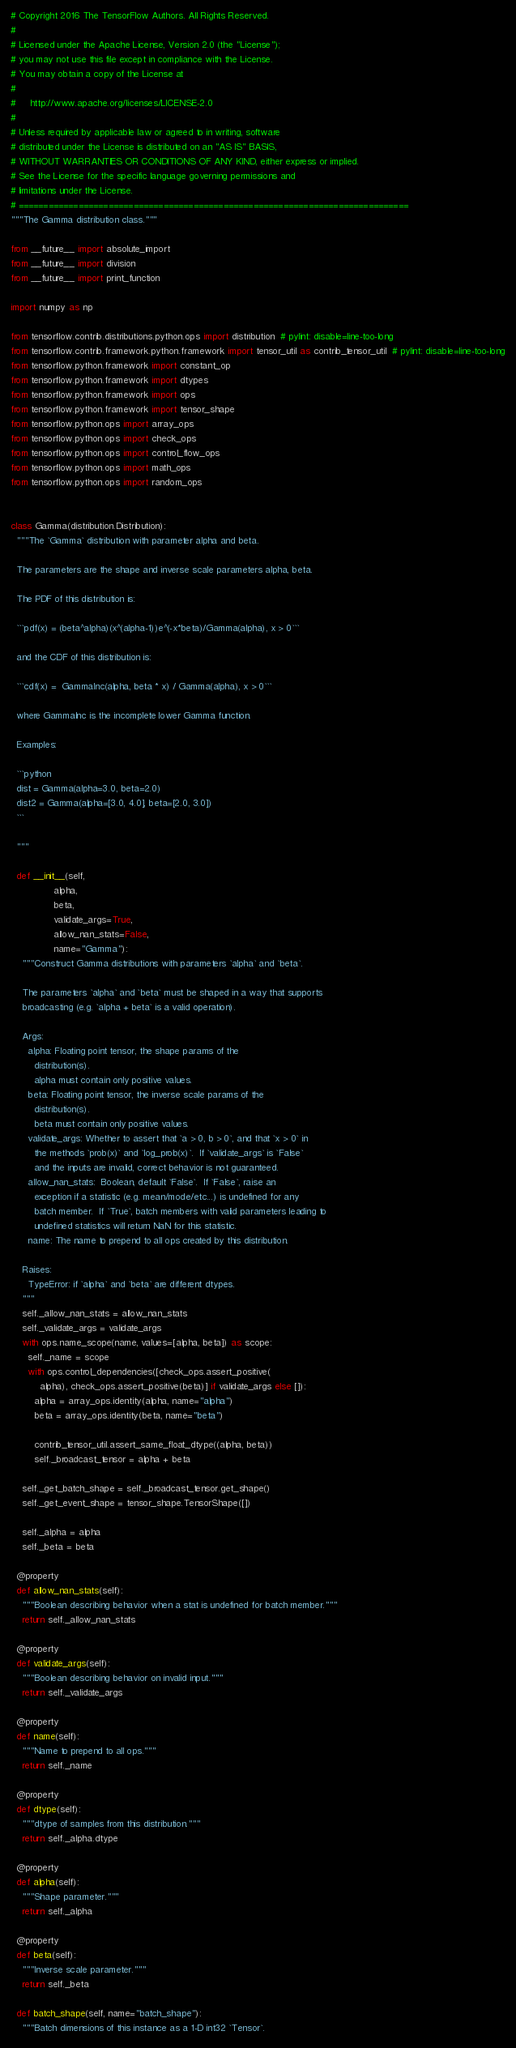Convert code to text. <code><loc_0><loc_0><loc_500><loc_500><_Python_># Copyright 2016 The TensorFlow Authors. All Rights Reserved.
#
# Licensed under the Apache License, Version 2.0 (the "License");
# you may not use this file except in compliance with the License.
# You may obtain a copy of the License at
#
#     http://www.apache.org/licenses/LICENSE-2.0
#
# Unless required by applicable law or agreed to in writing, software
# distributed under the License is distributed on an "AS IS" BASIS,
# WITHOUT WARRANTIES OR CONDITIONS OF ANY KIND, either express or implied.
# See the License for the specific language governing permissions and
# limitations under the License.
# ==============================================================================
"""The Gamma distribution class."""

from __future__ import absolute_import
from __future__ import division
from __future__ import print_function

import numpy as np

from tensorflow.contrib.distributions.python.ops import distribution  # pylint: disable=line-too-long
from tensorflow.contrib.framework.python.framework import tensor_util as contrib_tensor_util  # pylint: disable=line-too-long
from tensorflow.python.framework import constant_op
from tensorflow.python.framework import dtypes
from tensorflow.python.framework import ops
from tensorflow.python.framework import tensor_shape
from tensorflow.python.ops import array_ops
from tensorflow.python.ops import check_ops
from tensorflow.python.ops import control_flow_ops
from tensorflow.python.ops import math_ops
from tensorflow.python.ops import random_ops


class Gamma(distribution.Distribution):
  """The `Gamma` distribution with parameter alpha and beta.

  The parameters are the shape and inverse scale parameters alpha, beta.

  The PDF of this distribution is:

  ```pdf(x) = (beta^alpha)(x^(alpha-1))e^(-x*beta)/Gamma(alpha), x > 0```

  and the CDF of this distribution is:

  ```cdf(x) =  GammaInc(alpha, beta * x) / Gamma(alpha), x > 0```

  where GammaInc is the incomplete lower Gamma function.

  Examples:

  ```python
  dist = Gamma(alpha=3.0, beta=2.0)
  dist2 = Gamma(alpha=[3.0, 4.0], beta=[2.0, 3.0])
  ```

  """

  def __init__(self,
               alpha,
               beta,
               validate_args=True,
               allow_nan_stats=False,
               name="Gamma"):
    """Construct Gamma distributions with parameters `alpha` and `beta`.

    The parameters `alpha` and `beta` must be shaped in a way that supports
    broadcasting (e.g. `alpha + beta` is a valid operation).

    Args:
      alpha: Floating point tensor, the shape params of the
        distribution(s).
        alpha must contain only positive values.
      beta: Floating point tensor, the inverse scale params of the
        distribution(s).
        beta must contain only positive values.
      validate_args: Whether to assert that `a > 0, b > 0`, and that `x > 0` in
        the methods `prob(x)` and `log_prob(x)`.  If `validate_args` is `False`
        and the inputs are invalid, correct behavior is not guaranteed.
      allow_nan_stats:  Boolean, default `False`.  If `False`, raise an
        exception if a statistic (e.g. mean/mode/etc...) is undefined for any
        batch member.  If `True`, batch members with valid parameters leading to
        undefined statistics will return NaN for this statistic.
      name: The name to prepend to all ops created by this distribution.

    Raises:
      TypeError: if `alpha` and `beta` are different dtypes.
    """
    self._allow_nan_stats = allow_nan_stats
    self._validate_args = validate_args
    with ops.name_scope(name, values=[alpha, beta]) as scope:
      self._name = scope
      with ops.control_dependencies([check_ops.assert_positive(
          alpha), check_ops.assert_positive(beta)] if validate_args else []):
        alpha = array_ops.identity(alpha, name="alpha")
        beta = array_ops.identity(beta, name="beta")

        contrib_tensor_util.assert_same_float_dtype((alpha, beta))
        self._broadcast_tensor = alpha + beta

    self._get_batch_shape = self._broadcast_tensor.get_shape()
    self._get_event_shape = tensor_shape.TensorShape([])

    self._alpha = alpha
    self._beta = beta

  @property
  def allow_nan_stats(self):
    """Boolean describing behavior when a stat is undefined for batch member."""
    return self._allow_nan_stats

  @property
  def validate_args(self):
    """Boolean describing behavior on invalid input."""
    return self._validate_args

  @property
  def name(self):
    """Name to prepend to all ops."""
    return self._name

  @property
  def dtype(self):
    """dtype of samples from this distribution."""
    return self._alpha.dtype

  @property
  def alpha(self):
    """Shape parameter."""
    return self._alpha

  @property
  def beta(self):
    """Inverse scale parameter."""
    return self._beta

  def batch_shape(self, name="batch_shape"):
    """Batch dimensions of this instance as a 1-D int32 `Tensor`.
</code> 